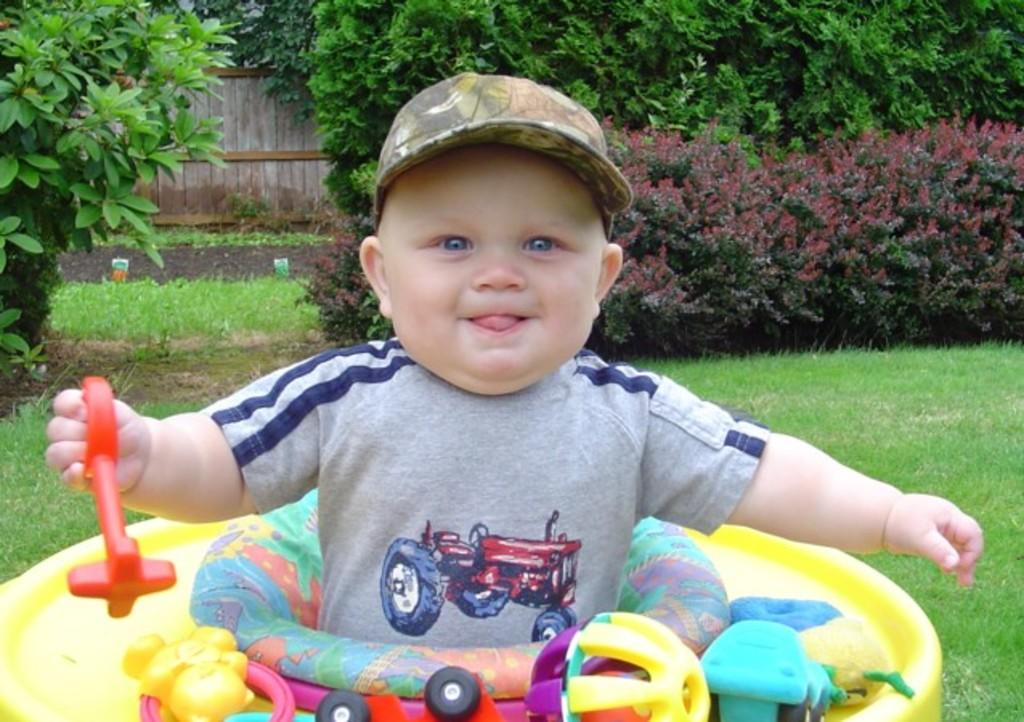What is the main subject of the image? There is a toddler in the image. What is the toddler doing in the image? The toddler is smiling and holding an object. How is the toddler supported in the image? The toddler is visible on a walker. What can be seen in the background of the image? There are bushes, plants, and a fence visible in the background of the image. Can you see any fairies flying around the toddler in the image? There are no fairies visible in the image. What is the toddler doing with their tongue in the image? The toddler's tongue is not visible or mentioned in the image, so we cannot determine what they might be doing with it. 